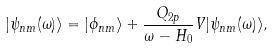<formula> <loc_0><loc_0><loc_500><loc_500>| \psi _ { n m } ( \omega ) \rangle = | \phi _ { n m } \rangle + \frac { Q _ { 2 p } } { \omega - H _ { 0 } } V | \psi _ { n m } ( \omega ) \rangle ,</formula> 